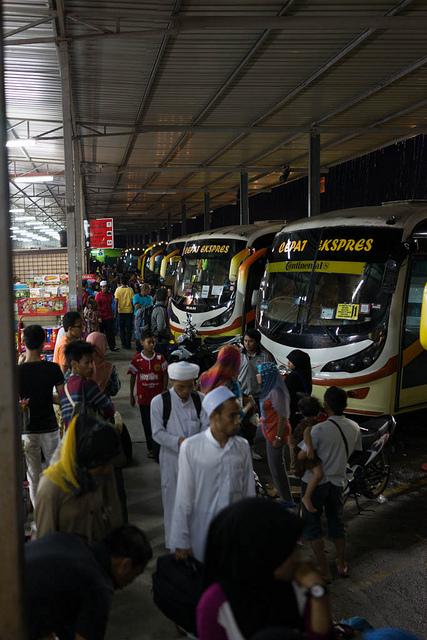How many people are wearing a white hat?
Quick response, please. 2. Is this a public area?
Keep it brief. Yes. What kind of vehicles are featured in the picture?
Give a very brief answer. Buses. 